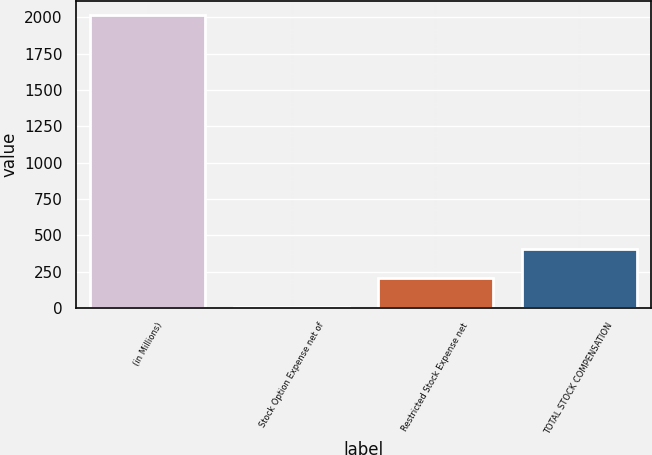Convert chart to OTSL. <chart><loc_0><loc_0><loc_500><loc_500><bar_chart><fcel>(in Millions)<fcel>Stock Option Expense net of<fcel>Restricted Stock Expense net<fcel>TOTAL STOCK COMPENSATION<nl><fcel>2015<fcel>4.1<fcel>205.19<fcel>406.28<nl></chart> 